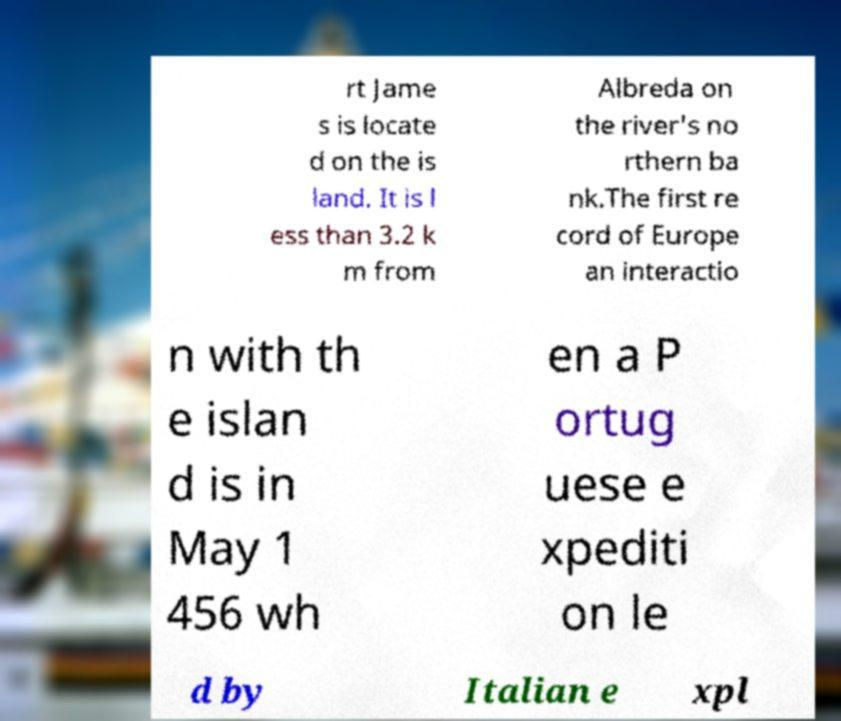Could you assist in decoding the text presented in this image and type it out clearly? rt Jame s is locate d on the is land. It is l ess than 3.2 k m from Albreda on the river's no rthern ba nk.The first re cord of Europe an interactio n with th e islan d is in May 1 456 wh en a P ortug uese e xpediti on le d by Italian e xpl 